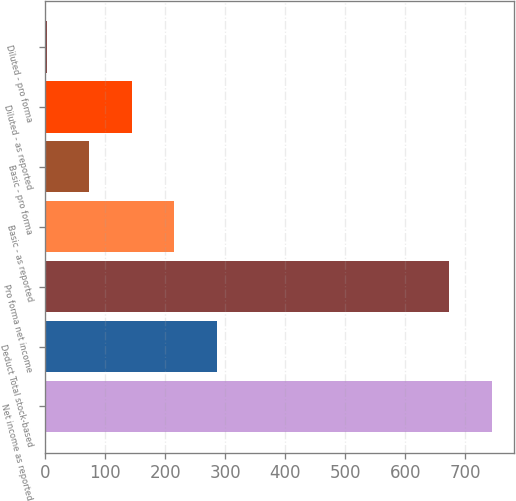Convert chart. <chart><loc_0><loc_0><loc_500><loc_500><bar_chart><fcel>Net income as reported<fcel>Deduct Total stock-based<fcel>Pro forma net income<fcel>Basic - as reported<fcel>Basic - pro forma<fcel>Diluted - as reported<fcel>Diluted - pro forma<nl><fcel>743.78<fcel>285.34<fcel>673<fcel>214.56<fcel>73<fcel>143.78<fcel>2.22<nl></chart> 